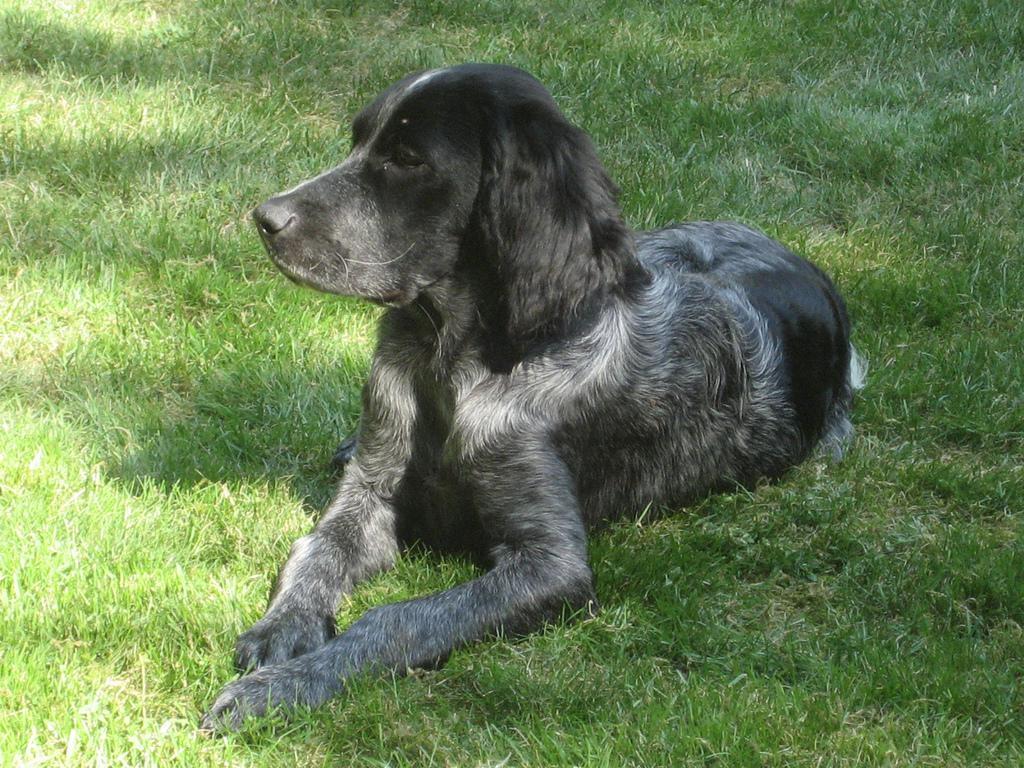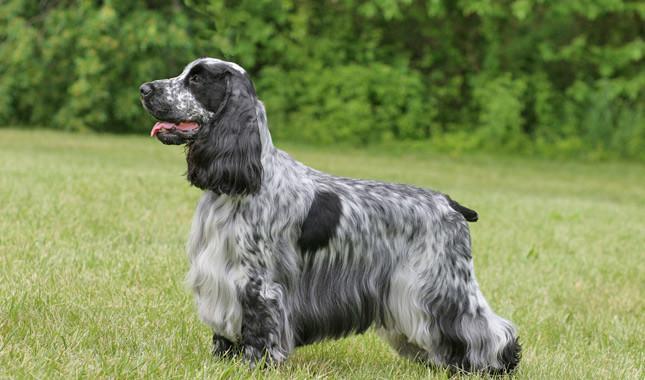The first image is the image on the left, the second image is the image on the right. Given the left and right images, does the statement "Right image shows at least one golden-haired dog sitting upright." hold true? Answer yes or no. No. 